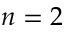Convert formula to latex. <formula><loc_0><loc_0><loc_500><loc_500>n = 2</formula> 